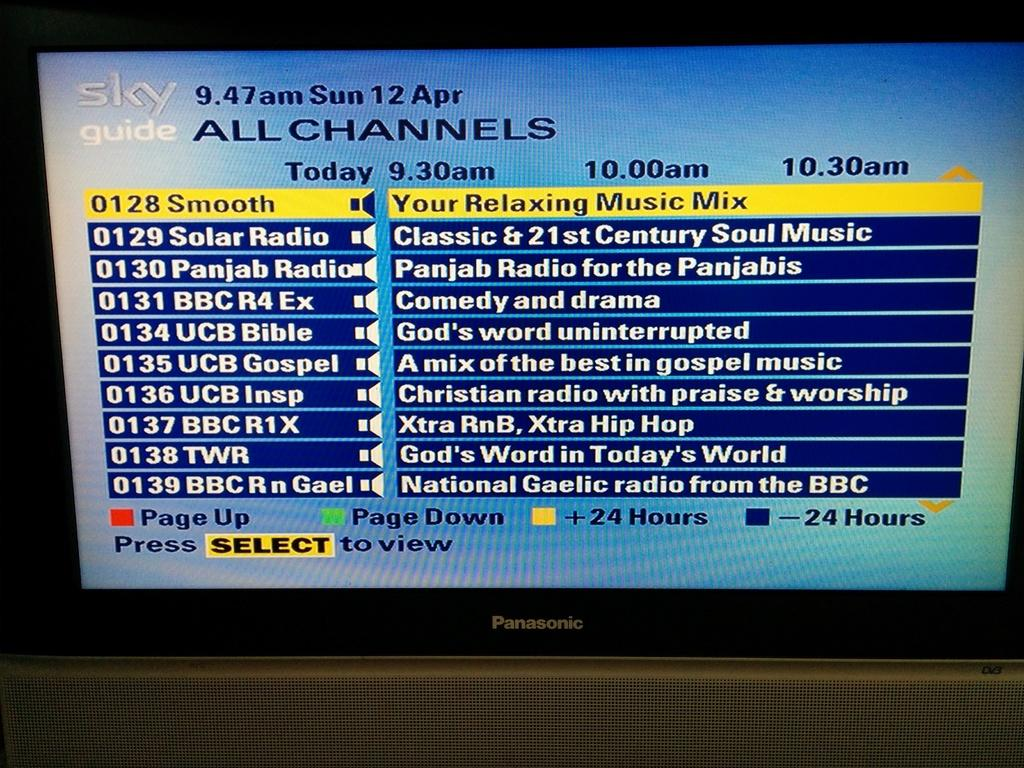<image>
Summarize the visual content of the image. The television channel directory called Sky Guide is displayed on a Panasonic television set. 